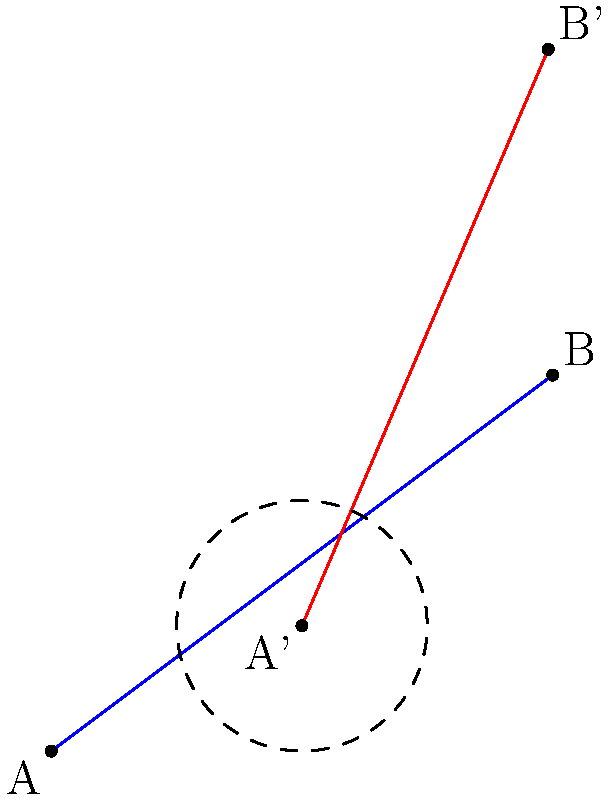Two satellites are initially positioned at points A(0,0) and B(4,3) in a 2D coordinate system. The entire system undergoes a 30° clockwise rotation around the origin, followed by a translation of (2,1). Calculate the distance between the two satellites after these transformations. To solve this problem, we'll follow these steps:

1) First, we need to apply the rotation to both points:
   Rotation matrix for 30° clockwise: 
   $$R = \begin{pmatrix} \cos 30° & \sin 30° \\ -\sin 30° & \cos 30° \end{pmatrix} = \begin{pmatrix} \frac{\sqrt{3}}{2} & \frac{1}{2} \\ -\frac{1}{2} & \frac{\sqrt{3}}{2} \end{pmatrix}$$

   For A(0,0):
   $$A' = R \cdot A = \begin{pmatrix} \frac{\sqrt{3}}{2} & \frac{1}{2} \\ -\frac{1}{2} & \frac{\sqrt{3}}{2} \end{pmatrix} \begin{pmatrix} 0 \\ 0 \end{pmatrix} = \begin{pmatrix} 0 \\ 0 \end{pmatrix}$$

   For B(4,3):
   $$B' = R \cdot B = \begin{pmatrix} \frac{\sqrt{3}}{2} & \frac{1}{2} \\ -\frac{1}{2} & \frac{\sqrt{3}}{2} \end{pmatrix} \begin{pmatrix} 4 \\ 3 \end{pmatrix} = \begin{pmatrix} 2\sqrt{3} + \frac{3}{2} \\ -2 + \frac{3\sqrt{3}}{2} \end{pmatrix}$$

2) Now, we apply the translation (2,1) to both points:
   $$A'' = (0,0) + (2,1) = (2,1)$$
   $$B'' = (2\sqrt{3} + \frac{3}{2}, -2 + \frac{3\sqrt{3}}{2}) + (2,1) = (2\sqrt{3} + \frac{7}{2}, -1 + \frac{3\sqrt{3}}{2})$$

3) To find the distance between these points, we use the distance formula:
   $$d = \sqrt{(x_2-x_1)^2 + (y_2-y_1)^2}$$
   
   $$d = \sqrt{((2\sqrt{3} + \frac{7}{2}) - 2)^2 + ((-1 + \frac{3\sqrt{3}}{2}) - 1)^2}$$
   
   $$d = \sqrt{(2\sqrt{3} + \frac{3}{2})^2 + (-2 + \frac{3\sqrt{3}}{2})^2}$$

4) Simplifying:
   $$d = \sqrt{12 + 6\sqrt{3} + \frac{9}{4} + 4 - 6\sqrt{3} + \frac{27}{4}} = \sqrt{16 + \frac{36}{4}} = \sqrt{25} = 5$$

Therefore, the distance between the satellites after the transformations is 5 units.
Answer: 5 units 